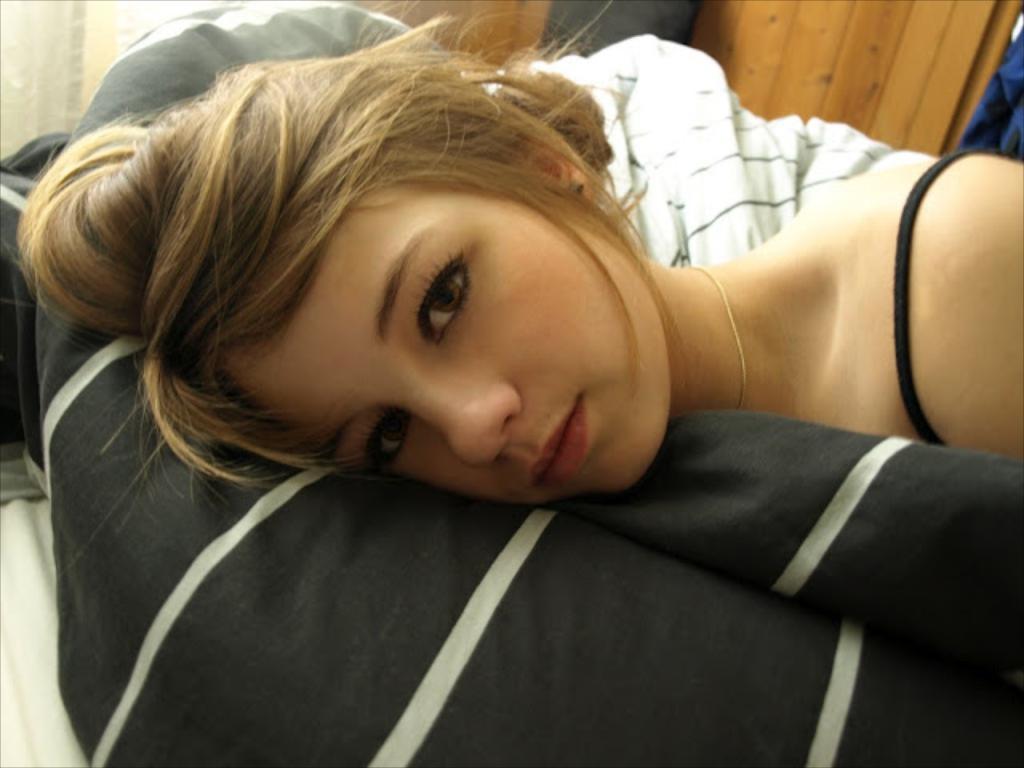Please provide a concise description of this image. In this image there is a person laying on the black color cloth, and in the background there are cloths, wooden wall. 